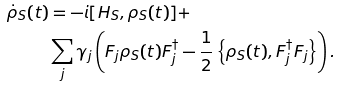<formula> <loc_0><loc_0><loc_500><loc_500>\dot { \rho } _ { S } ( t ) & = - i [ H _ { S } , \rho _ { S } ( t ) ] + \\ & \sum _ { j } \gamma _ { j } \left ( F _ { j } \rho _ { S } ( t ) F _ { j } ^ { \dagger } - \frac { 1 } { 2 } \left \{ \rho _ { S } ( t ) , F _ { j } ^ { \dagger } F _ { j } \right \} \right ) .</formula> 